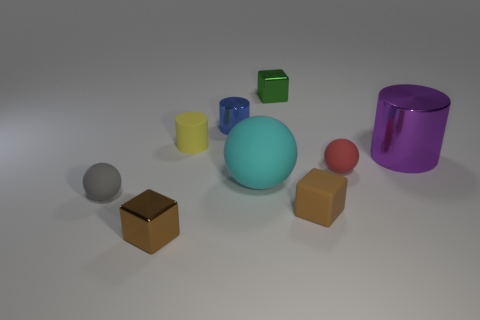Add 8 tiny yellow objects. How many tiny yellow objects exist? 9 Subtract all brown blocks. How many blocks are left? 1 Subtract all tiny blue shiny cylinders. How many cylinders are left? 2 Subtract 1 green cubes. How many objects are left? 8 Subtract 1 spheres. How many spheres are left? 2 Subtract all purple blocks. Subtract all green balls. How many blocks are left? 3 Subtract all cyan cylinders. How many cyan balls are left? 1 Subtract all small shiny cubes. Subtract all tiny blue things. How many objects are left? 6 Add 4 small green metal objects. How many small green metal objects are left? 5 